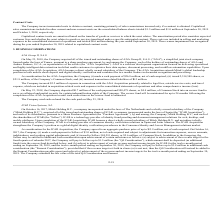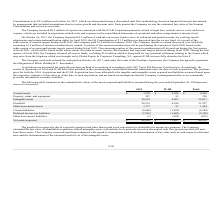From Mitek Systems's financial document, How much money did the Company deposit into an escrow fund in 2017 and 2018, respectively?  The document shows two values: $1.5 million and $1.5 million. From the document: "assets on the consolidated balance sheets totaled $1.5 million and $1.0 million at September 30, 2019 and October 1, 2018, respectively. assets on the..." Also, What is the total net assets acquired from A2iA? According to the financial document, $48,816 (in thousands). The relevant text states: "Net assets acquired $ 48,816 $ 11,467 $ 60,283..." Also, What are the estimated fair values of intangible assets of A2iA and ICAR Acquisition, respectively? The document shows two values: 28,610 and 6,407 (in thousands). From the document: "Intangible assets 28,610 6,407 35,017 Intangible assets 28,610 6,407 35,017..." Additionally, Which acquisition has the highest net assets? According to the financial document, A2iA. The relevant text states: "A2iA ICAR Total..." Also, can you calculate: What is the average of net assets from both A2iA and ICAR acquisitions? To answer this question, I need to perform calculations using the financial data. The calculation is: (48,816+11,467)/2 , which equals 30141.5 (in thousands). This is based on the information: "Net assets acquired $ 48,816 $ 11,467 $ 60,283 Net assets acquired $ 48,816 $ 11,467 $ 60,283..." The key data points involved are: 11,467, 48,816. Also, can you calculate: What are the total liabilities from both A2iA and ICAR acquisitions? Based on the calculation: 2,688+7,503+7+1,652+1,602+828 , the result is 14280 (in thousands). This is based on the information: "Other non-current liabilities (7) (828) (835) Deferred income tax liabilities (7,503) (1,602) (9,105) Current liabilities (2,688) (1,652) (4,340) Deferred income tax liabilities (7,503) (1,602) (9,105..." The key data points involved are: 1,602, 1,652, 2,688. 